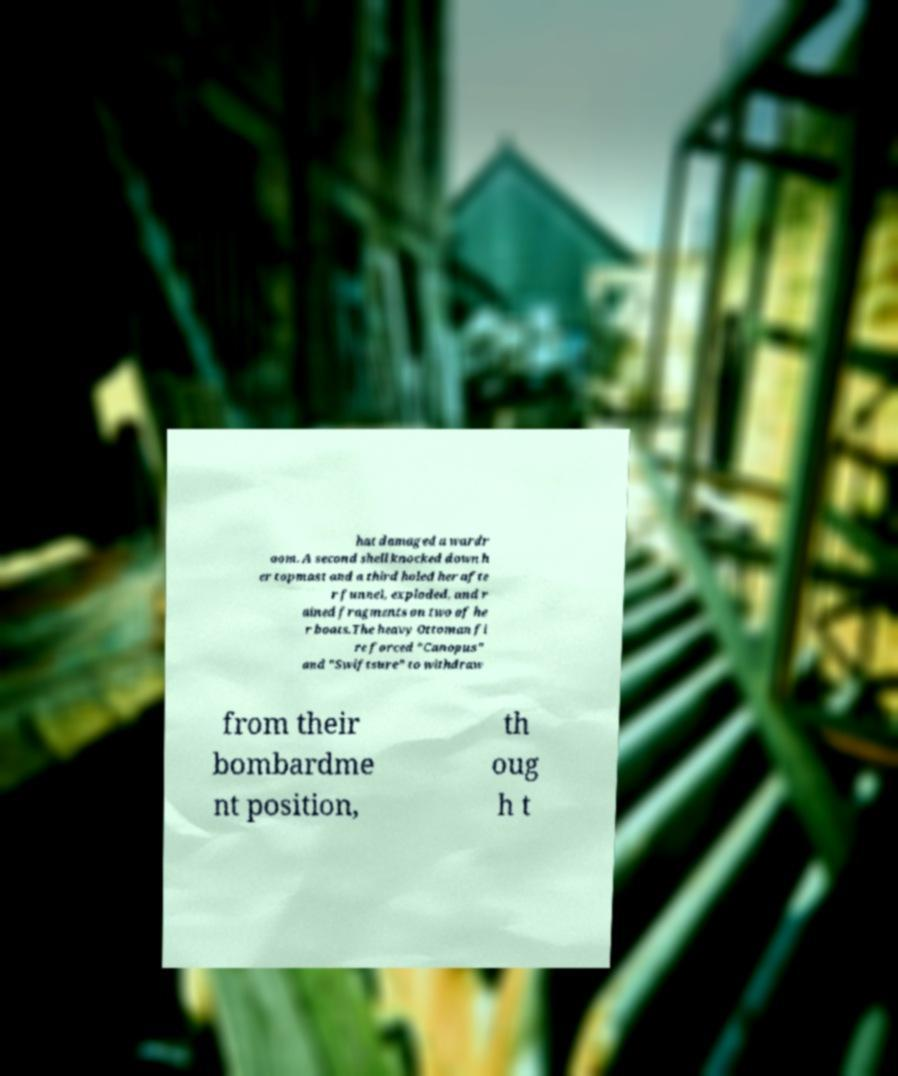There's text embedded in this image that I need extracted. Can you transcribe it verbatim? hat damaged a wardr oom. A second shell knocked down h er topmast and a third holed her afte r funnel, exploded, and r ained fragments on two of he r boats.The heavy Ottoman fi re forced "Canopus" and "Swiftsure" to withdraw from their bombardme nt position, th oug h t 